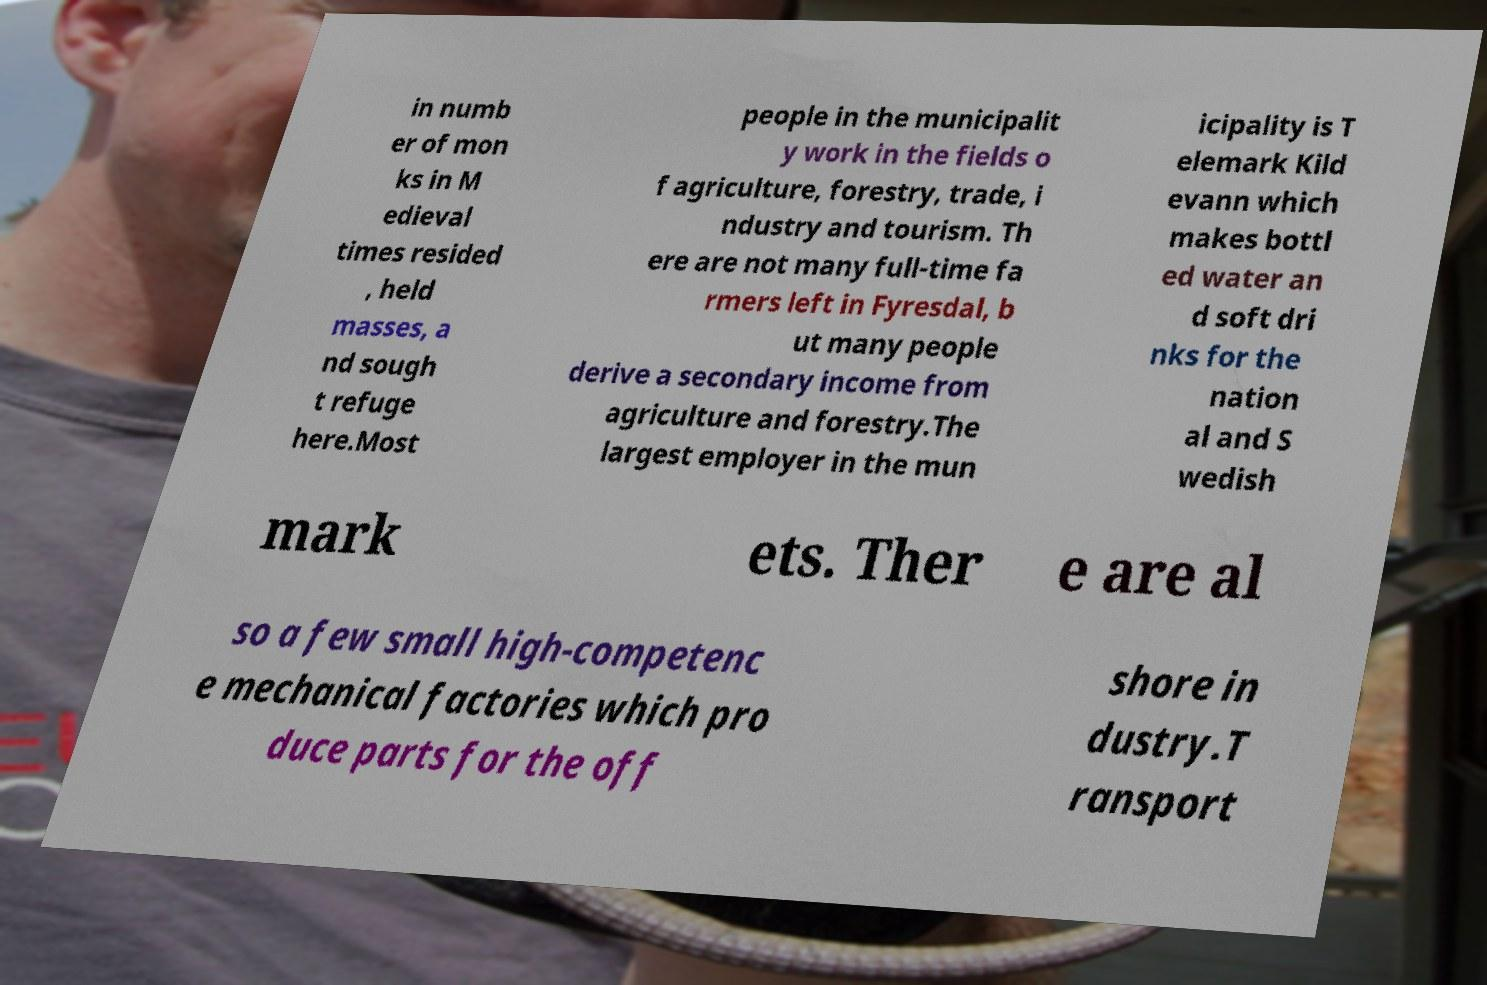For documentation purposes, I need the text within this image transcribed. Could you provide that? in numb er of mon ks in M edieval times resided , held masses, a nd sough t refuge here.Most people in the municipalit y work in the fields o f agriculture, forestry, trade, i ndustry and tourism. Th ere are not many full-time fa rmers left in Fyresdal, b ut many people derive a secondary income from agriculture and forestry.The largest employer in the mun icipality is T elemark Kild evann which makes bottl ed water an d soft dri nks for the nation al and S wedish mark ets. Ther e are al so a few small high-competenc e mechanical factories which pro duce parts for the off shore in dustry.T ransport 